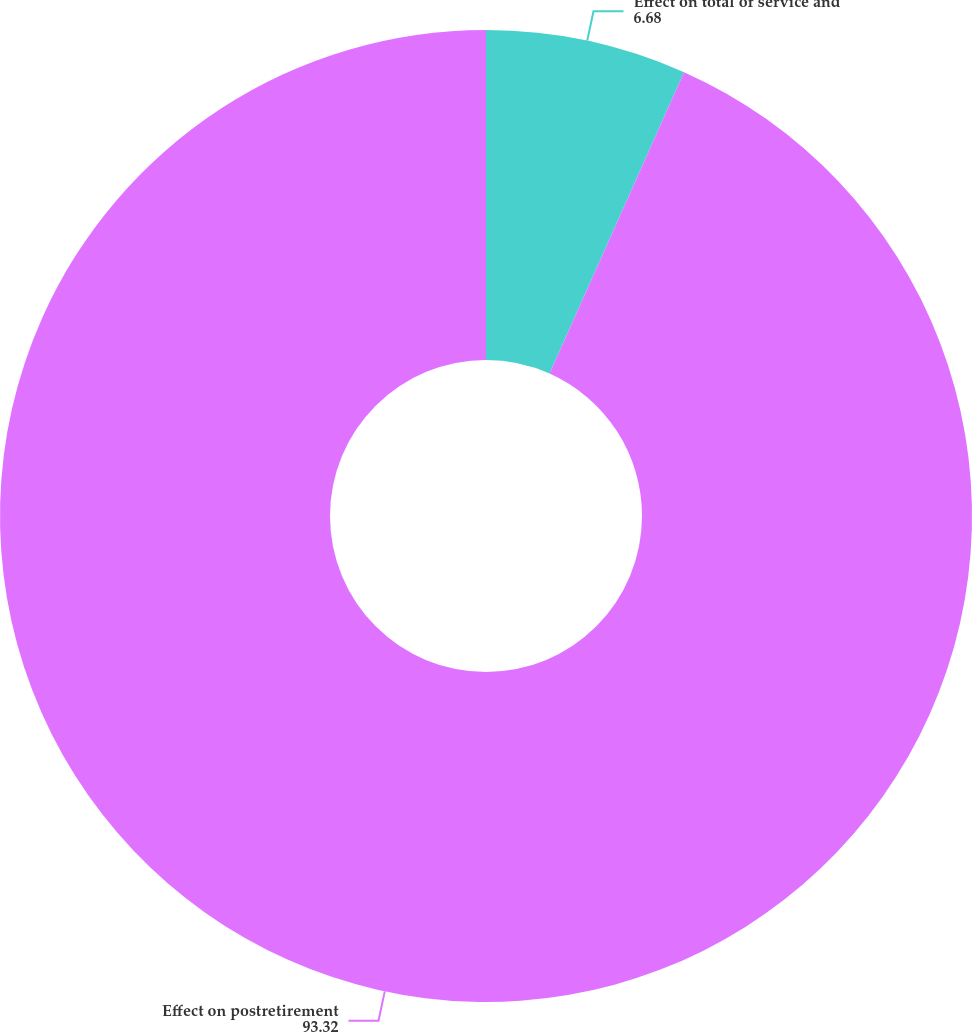<chart> <loc_0><loc_0><loc_500><loc_500><pie_chart><fcel>Effect on total of service and<fcel>Effect on postretirement<nl><fcel>6.68%<fcel>93.32%<nl></chart> 